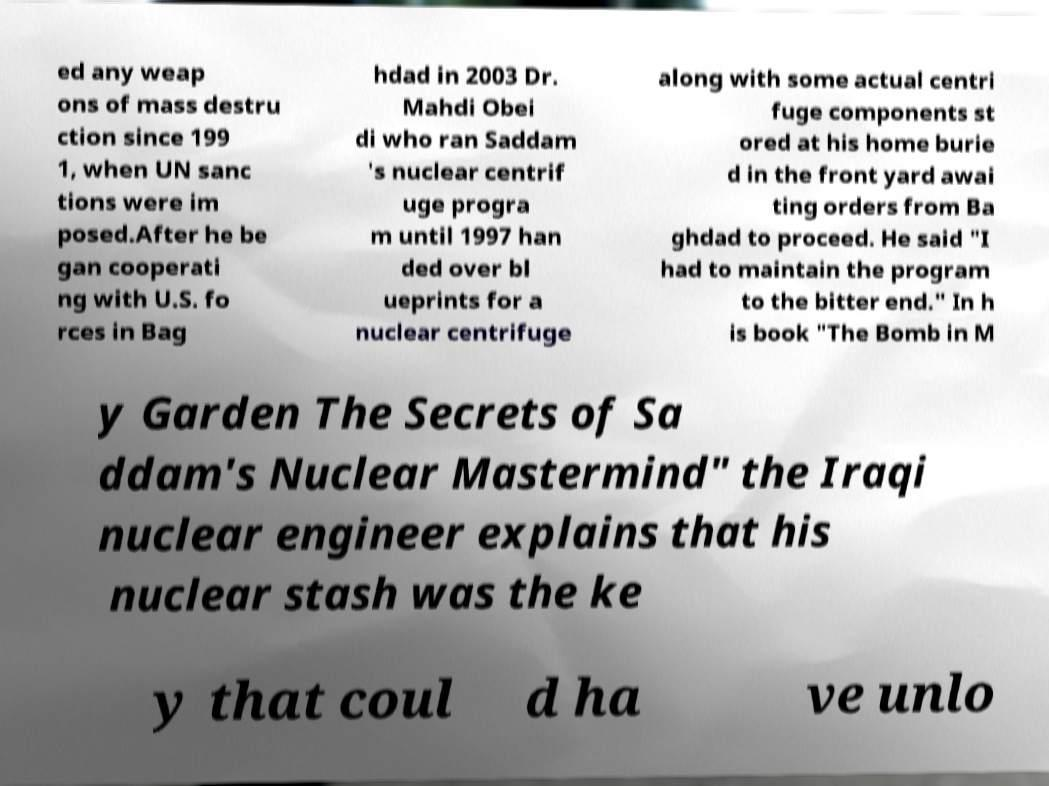What messages or text are displayed in this image? I need them in a readable, typed format. ed any weap ons of mass destru ction since 199 1, when UN sanc tions were im posed.After he be gan cooperati ng with U.S. fo rces in Bag hdad in 2003 Dr. Mahdi Obei di who ran Saddam 's nuclear centrif uge progra m until 1997 han ded over bl ueprints for a nuclear centrifuge along with some actual centri fuge components st ored at his home burie d in the front yard awai ting orders from Ba ghdad to proceed. He said "I had to maintain the program to the bitter end." In h is book "The Bomb in M y Garden The Secrets of Sa ddam's Nuclear Mastermind" the Iraqi nuclear engineer explains that his nuclear stash was the ke y that coul d ha ve unlo 